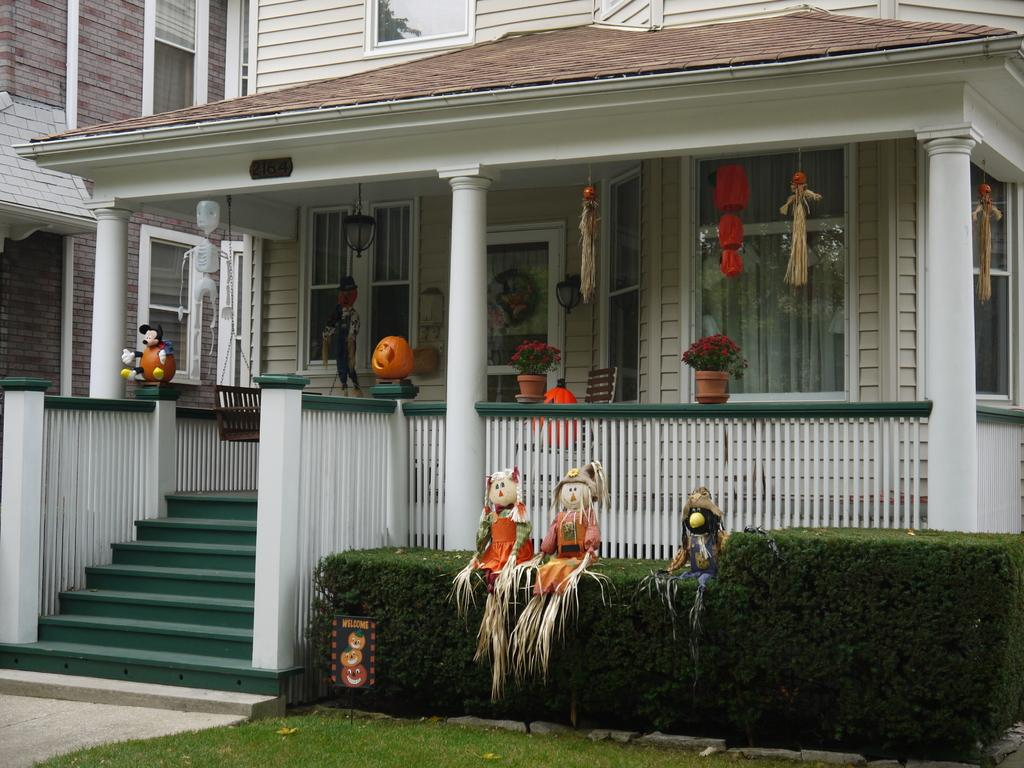What type of structure is visible in the image? There is a house in the image. What is located in front of the house? There is a garden in front of the house. What can be found in the garden? There are toys in the garden. What type of hobbies does the house system enjoy? There is no information about a house system or its hobbies in the image. 